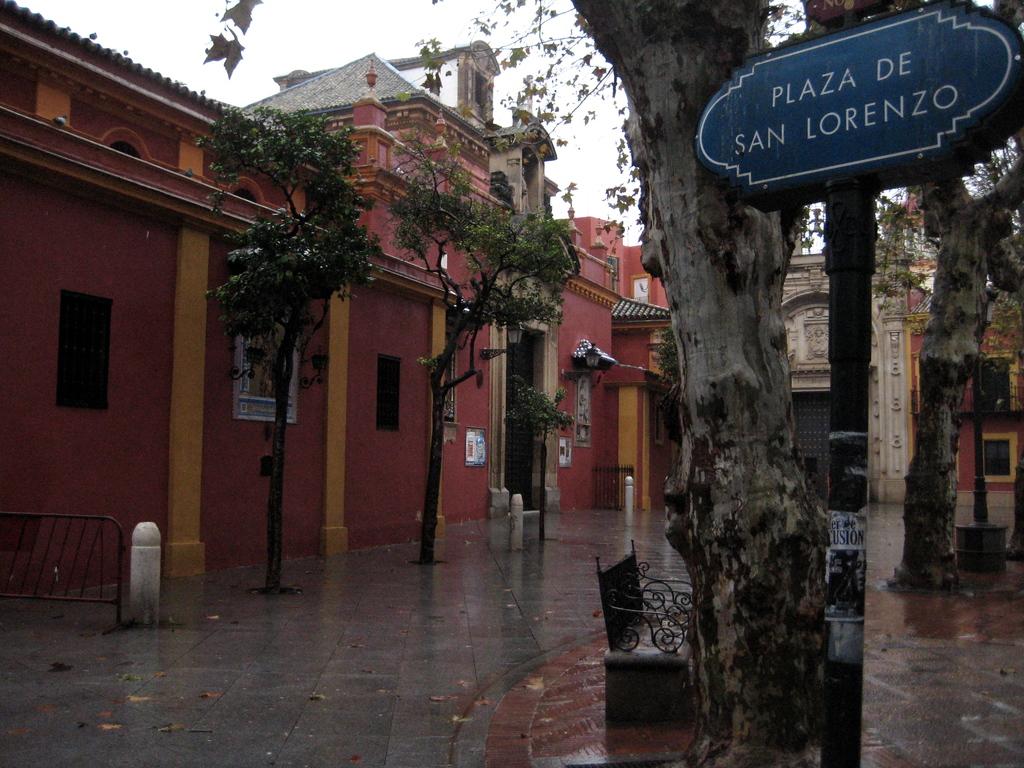What's the name of this plaza?
Your response must be concise. Plaza de san lorenzo. 